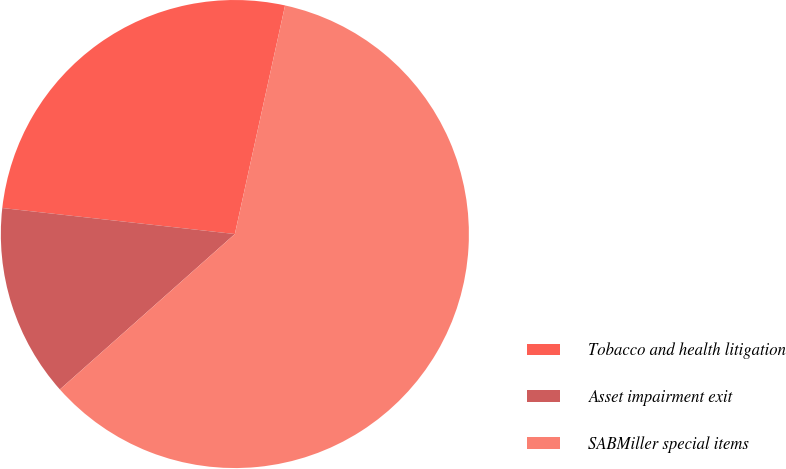Convert chart to OTSL. <chart><loc_0><loc_0><loc_500><loc_500><pie_chart><fcel>Tobacco and health litigation<fcel>Asset impairment exit<fcel>SABMiller special items<nl><fcel>26.67%<fcel>13.33%<fcel>60.0%<nl></chart> 